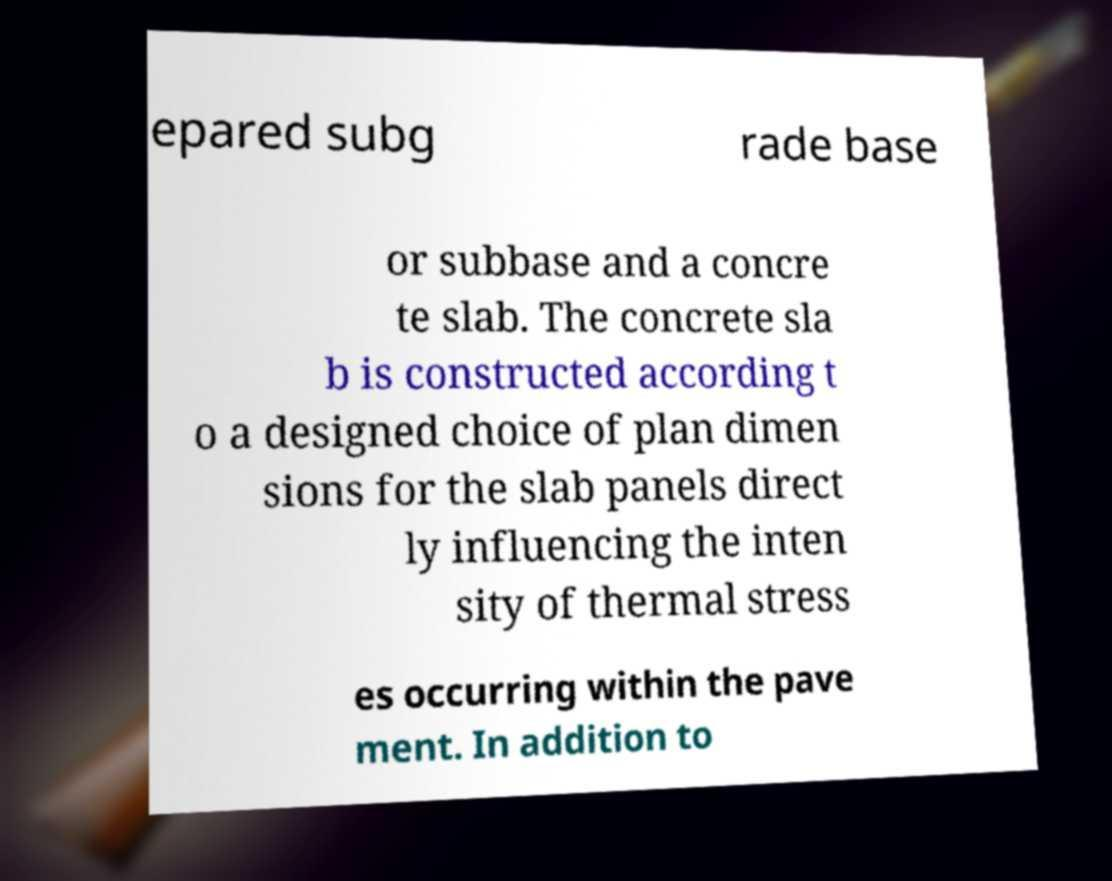Could you assist in decoding the text presented in this image and type it out clearly? epared subg rade base or subbase and a concre te slab. The concrete sla b is constructed according t o a designed choice of plan dimen sions for the slab panels direct ly influencing the inten sity of thermal stress es occurring within the pave ment. In addition to 